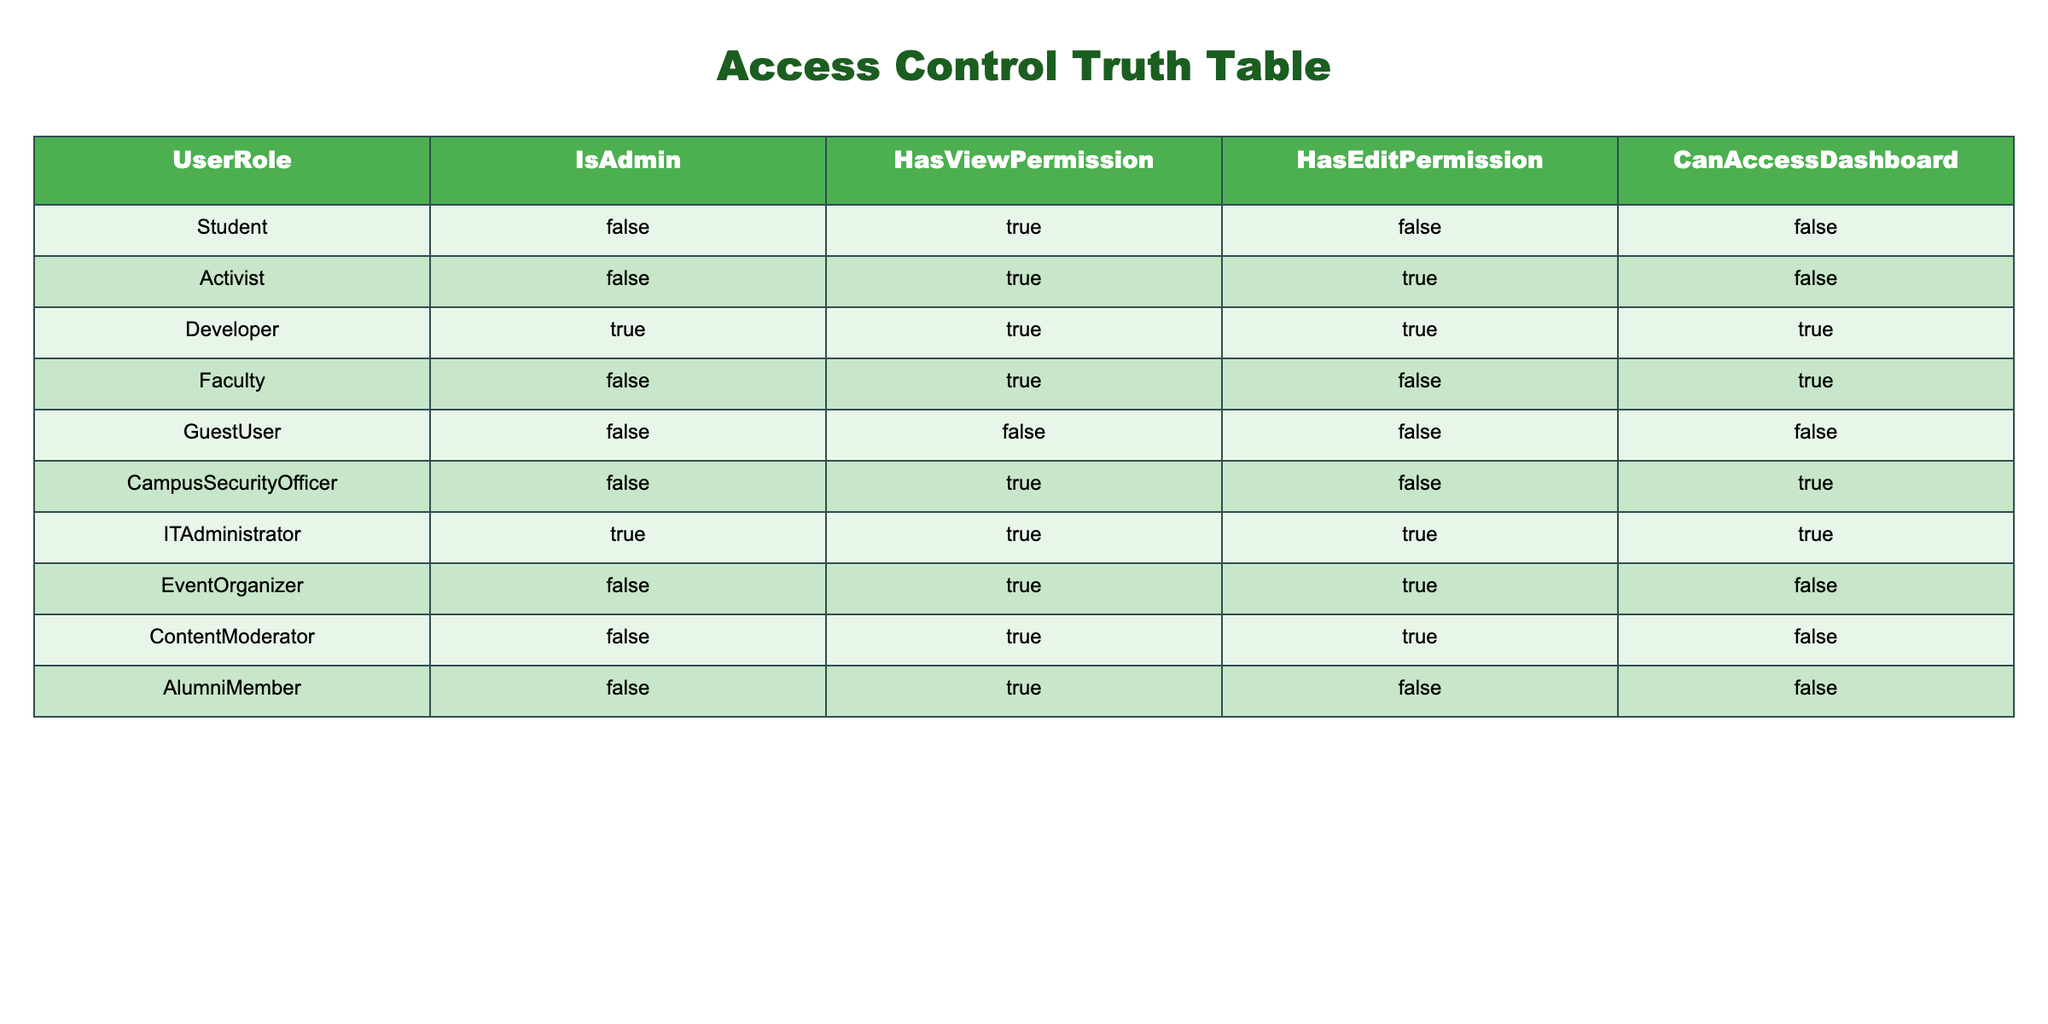What is the access status of a Student? A Student has the following permissions: IsAdmin = FALSE, HasViewPermission = TRUE, HasEditPermission = FALSE, CanAccessDashboard = FALSE. This information is directly taken from the row corresponding to the Student role in the table.
Answer: FALSE, TRUE, FALSE, FALSE Which user role has both HasViewPermission and HasEditPermission set to TRUE? Looking through the table, the Activist, Developer, and ContentModerator roles have HasViewPermission = TRUE. Among these, only the Activist and Developer have HasEditPermission = TRUE. Thus, the roles with both permissions are Activist and Developer.
Answer: Activist, Developer Is ITAdministrator able to access the dashboard? Checking the row for the ITAdministrator, we see that CanAccessDashboard = TRUE. Therefore, the ITAdministrator can access the dashboard.
Answer: YES How many roles have IsAdmin set to TRUE? The roles with IsAdmin = TRUE are Developer and ITAdministrator. Counting these gives us a total of 2 roles.
Answer: 2 Which user role has the highest number of permissions (view, edit, and admin combined)? First, let's summarize the permissions: Developer and ITAdministrator both have all three permissions (IsAdmin = TRUE, HasViewPermission = TRUE, HasEditPermission = TRUE). Therefore, they have the highest number of permissions. There are two roles that meet this criterion.
Answer: Developer, ITAdministrator Are there any roles without any permissions? The roles that have all permissions as FALSE are Student and GuestUser. Thus, they do not have any permissions.
Answer: YES What percentage of the roles can access the dashboard? Among the roles, those that can access the dashboard are Developer, Faculty, and ITAdministrator. There are 10 roles in total. So, the percentage is (3/10) * 100 = 30%.
Answer: 30% Which user roles have view permission but not edit permission? Observing the table, the roles that have HasViewPermission = TRUE but HasEditPermission = FALSE are Student, Faculty, and AlumniMember. Hence, these roles fit the criteria.
Answer: Student, Faculty, AlumniMember How many user roles can edit but cannot access the dashboard? The roles with HasEditPermission = TRUE but CanAccessDashboard = FALSE are Activist, EventOrganizer, and ContentModerator. Counting these gives us a total of 3 roles.
Answer: 3 